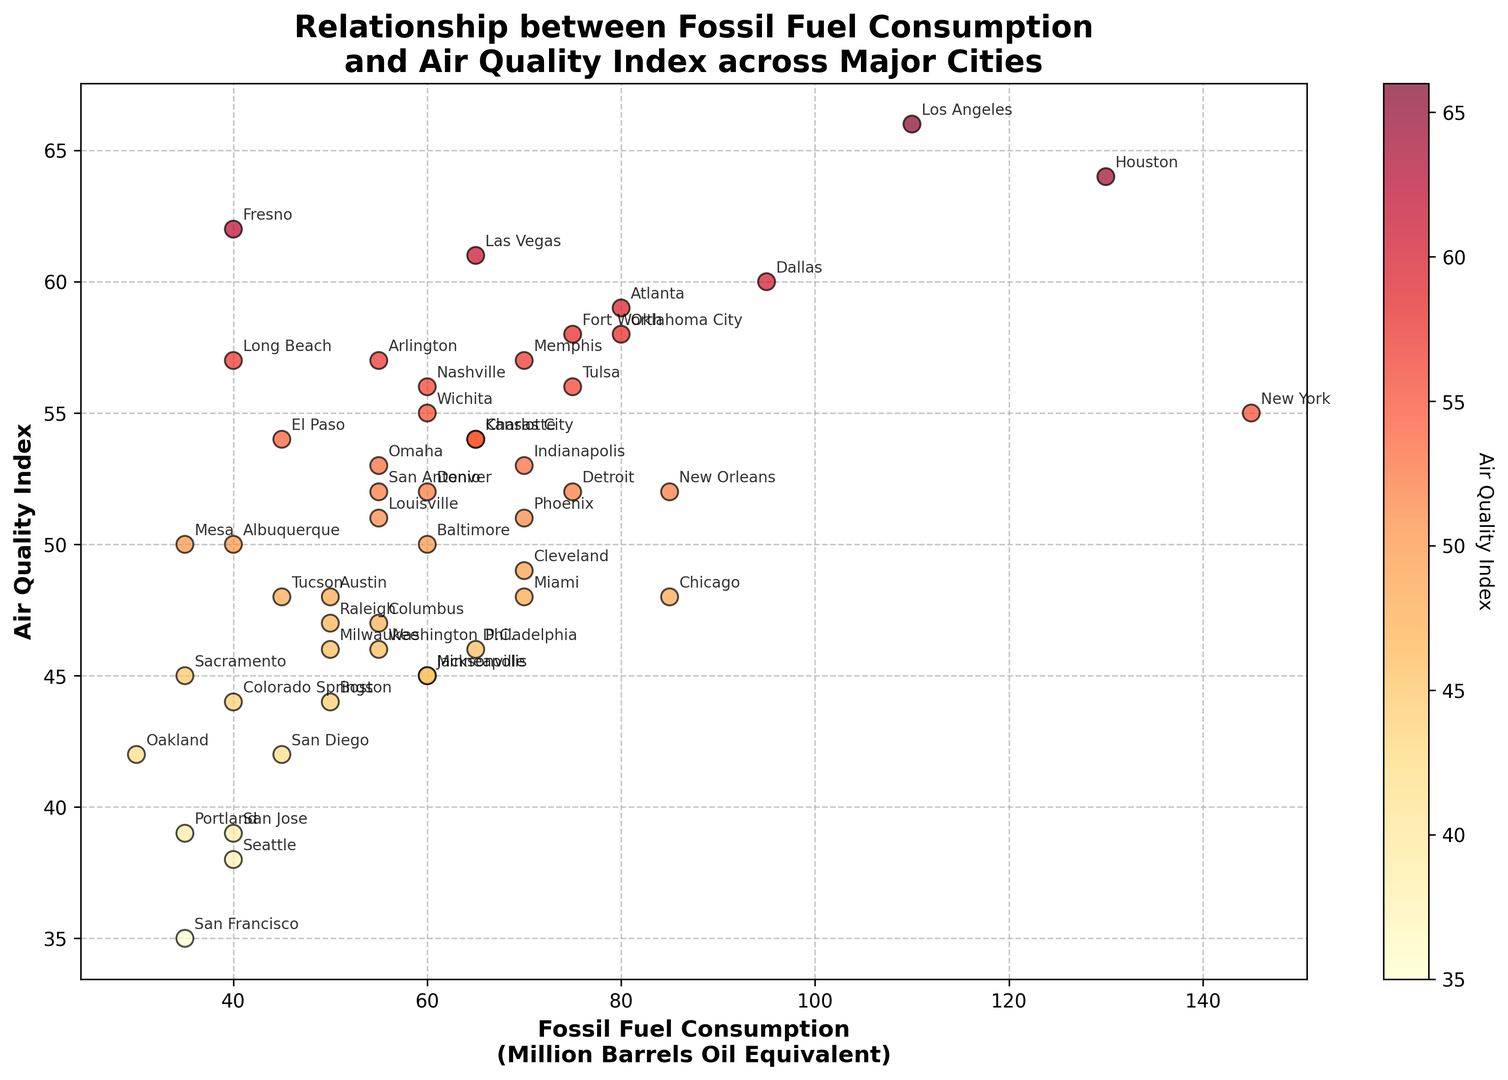What's the overall trend shown in the scatter plot regarding fossil fuel consumption and air quality? The scatter plot shows a general positive correlation between fossil fuel consumption and the air quality index. This means that as fossil fuel consumption increases, the air quality index also tends to increase. The data points are color-coded where higher air quality index values are more reddish, indicating poorer air quality.
Answer: Positive correlation Which city has the lowest air quality index and what is its fossil fuel consumption? The city with the lowest air quality index can be found at the lowest point on the y-axis of the scatter plot. San Francisco has the lowest air quality index value of 35, and its fossil fuel consumption is 35 million barrels of oil equivalent.
Answer: San Francisco, 35 million barrels Compare the air quality index of Los Angeles and Chicago. Which city has a higher value and by how much? Locate Los Angeles and Chicago data points on the plot. Los Angeles has an air quality index of 66, while Chicago has 48. The difference is 66 - 48 = 18. So, Los Angeles has a higher air quality index by 18.
Answer: Los Angeles, by 18 What is the average air quality index for cities with a fossil fuel consumption lower than 50 million barrels of oil equivalent? Cities with fossil fuel consumption below 50: San Diego (42), San Jose (39), San Francisco (35), Seattle (38), El Paso (54), Portland (39), Sacramento (45), Long Beach (57), Mesa (50), Colorado Springs (44), and Oakland (42). The sum of these values: 42 + 39 + 35 + 38 + 54 + 39 + 45 + 57 + 50 + 44 + 42 = 485. There are 11 cities, so the average is 485/11 ≈ 44.1
Answer: 44.1 Which cities have the same air quality index despite having different levels of fossil fuel consumption, and what is the shared index value? Look for cities that have the same y-value but different x-values. El Paso, Nashville, Arlington, and Kansas City all have an air quality index of 54. Despite their differing fossil fuel consumption, they share the same air quality index.
Answer: El Paso, Nashville, Arlington, Kansas City; 54 What is the fossil fuel consumption of the city with the highest air quality index? The highest air quality index value appears at the highest point on the y-axis. Los Angeles has the highest air quality index of 66, and its fossil fuel consumption is 110 million barrels of oil equivalent.
Answer: Los Angeles, 110 million barrels Compare the fossil fuel consumption and air quality index of Phoenix and Austin. Which city is better in terms of air quality and by what margin? Locate Phoenix and Austin. Phoenix has an air quality index of 51 and fossil fuel consumption of 70. Austin has an air quality index of 48 and fossil fuel consumption of 50. Phoenix’s index is 51, and Austin’s is 48. The difference is 51 - 48 = 3. Austin's air quality is better by 3 units.
Answer: Austin, by 3 Estimate the range of fossil fuel consumption among cities with an air quality index of 50 or below. Identify cities with an air quality index of 50 or below. They are Chicago (85), Phoenix (70), Philadelphia (65), San Diego (45), San Jose (40), Austin (50), Jacksonville (60), Columbus (55), San Francisco (35), Boston (50), Albuquerque (40), Tucson (45), Sacramento (35), Cleveland (70), Oakland (30), Minneapolis (60), and Miami (70). The minimum and maximum of these fossil fuel consumption values are 30 and 85, respectively. Therefore, the range is 85 - 30 = 55.
Answer: 55 Which city has the highest air quality index among cities with fossil fuel consumption of 60 or below? Identify cities with fossil fuel consumption of 60 or below: San Diego (42), San Jose (39), San Francisco (35), Seattle (38), El Paso (54), Fresno (62), Portland (39), Sacramento (45), Long Beach (57), Mesa (50), Colorado Springs (44), Oakland (42). Fresno has an air quality index of 62, which is the highest among these cities.
Answer: Fresno 